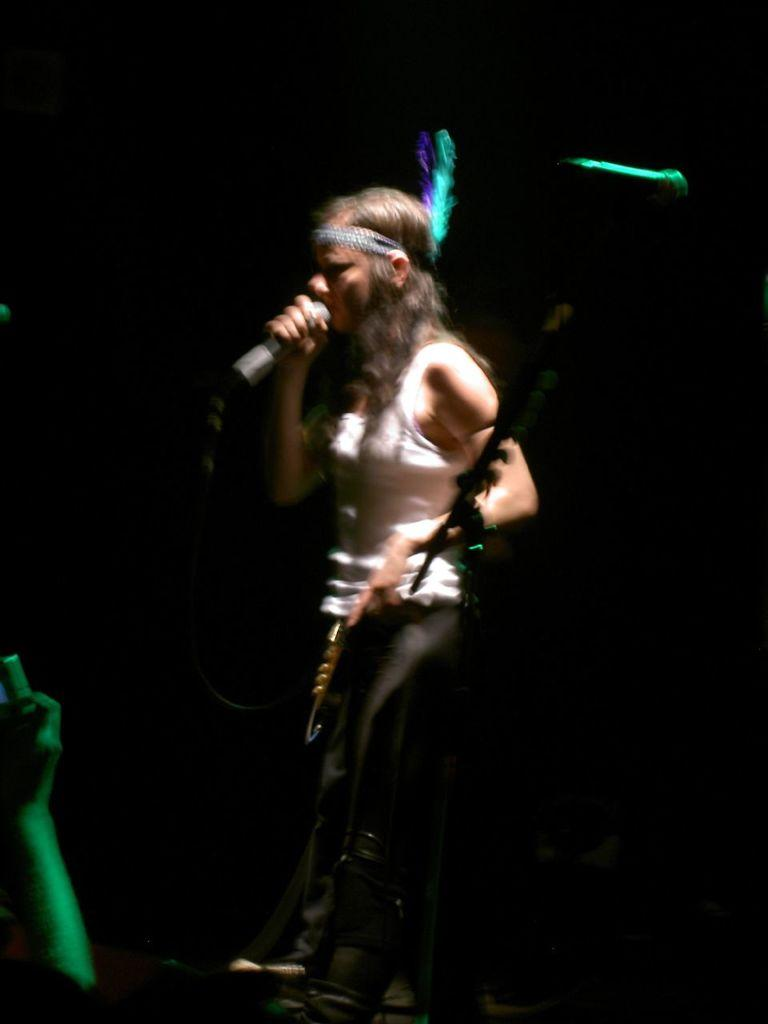Who is the main subject in the image? There is a woman in the image. What is the woman doing in the image? The woman is singing. What object is the woman holding in her hand? The woman is holding a mic in her hand. What type of worm can be seen crawling on the woman's shoulder in the image? There is no worm present in the image. 